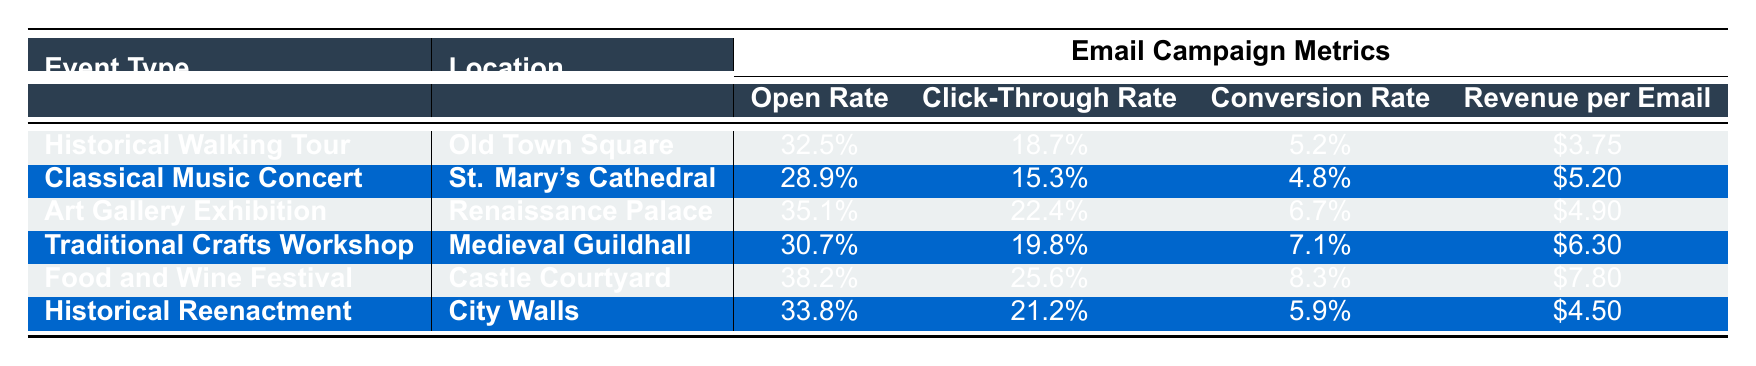What was the open rate for the Food and Wine Festival? The data shows that the open rate for the Food and Wine Festival is listed as 38.2%.
Answer: 38.2% Which event had the highest click-through rate? The table indicates that the Food and Wine Festival has the highest click-through rate of 25.6%.
Answer: Food and Wine Festival Is the conversion rate for the Art Gallery Exhibition higher than that for the Historical Walking Tour? The conversion rate for the Art Gallery Exhibition is 6.7%, while the Historical Walking Tour has a conversion rate of 5.2%. Since 6.7% is greater than 5.2%, the statement is true.
Answer: Yes What is the average revenue per email for events held in historical locations? The historical events are the Historical Walking Tour ($3.75), Classical Music Concert ($5.20), and Historical Reenactment ($4.50). The average is calculated as follows: (3.75 + 5.20 + 4.50) / 3 = 4.15.
Answer: $4.15 Did any event have a conversion rate of 8.3% or higher? The only event with a conversion rate of 8.3% or higher is the Food and Wine Festival, which has a conversion rate of 8.3%. Therefore, the answer is yes.
Answer: Yes What is the difference in revenue per email between the Traditional Crafts Workshop and the Food and Wine Festival? The revenue per email for the Traditional Crafts Workshop is $6.30 and for the Food and Wine Festival is $7.80. The difference is calculated as $7.80 - $6.30 = $1.50.
Answer: $1.50 Which event type had the lowest open rate? By comparing the open rates, the Classical Music Concert has the lowest open rate at 28.9%.
Answer: Classical Music Concert If we sum up the conversion rates of all events, what would be the total? The conversion rates are 5.2% for the Historical Walking Tour, 4.8% for the Classical Music Concert, 6.7% for the Art Gallery Exhibition, 7.1% for the Traditional Crafts Workshop, 8.3% for the Food and Wine Festival, and 5.9% for the Historical Reenactment. Summing these gives: 5.2 + 4.8 + 6.7 + 7.1 + 8.3 + 5.9 = 38.0%.
Answer: 38.0% Which event has both a click-through rate and a conversion rate greater than 20%? Reviewing the table, the Food and Wine Festival has a click-through rate of 25.6% and a conversion rate of 8.3%, which does not qualify. No other event meets both criteria.
Answer: None How many events had an open rate above 30%? Checking the open rates of each event, the Historical Walking Tour (32.5%), Art Gallery Exhibition (35.1%), Traditional Crafts Workshop (30.7%), and Food and Wine Festival (38.2%) all exceeded 30%. This totals to four events.
Answer: 4 